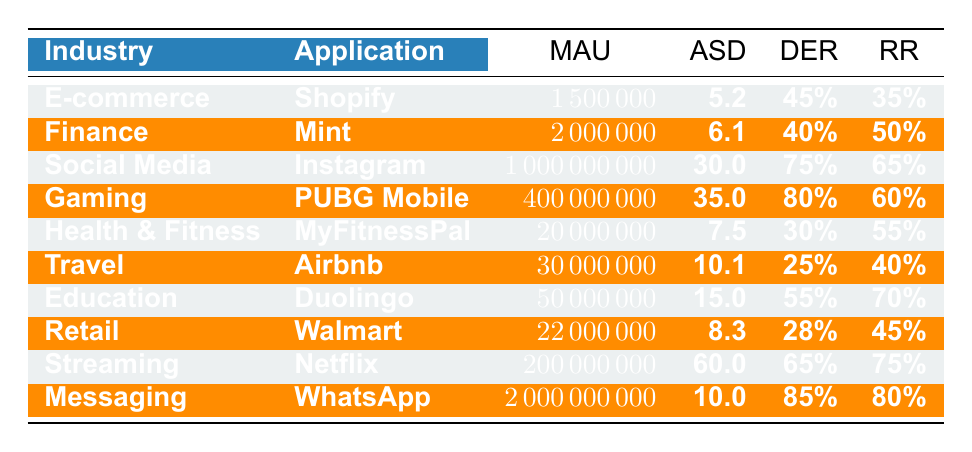What is the Monthly Active Users for WhatsApp? The table lists WhatsApp under the Messaging industry with a Monthly Active Users (MAU) count of 2,000,000,000.
Answer: 2,000,000,000 Which application has the longest Average Session Duration? From the table, PUBG Mobile has the highest Average Session Duration of 35.0 minutes among the listed applications.
Answer: PUBG Mobile What is the Daily Engagement Rate of Duolingo? The table indicates that Duolingo has a Daily Engagement Rate (DER) of 55%.
Answer: 55% Which industry has the highest Retention Rate and what is the value? By comparing the Retention Rates, Instagram has a Retention Rate of 65%, which is the highest in the table.
Answer: Social Media, 65% How do the Average Session Durations of health & fitness and travel apps compare? MyFitnessPal has an Average Session Duration of 7.5 minutes, while Airbnb has 10.1 minutes. Since 10.1 is greater than 7.5, Airbnb has a longer duration.
Answer: Airbnb has a longer duration If we average the Daily Engagement Rates of all industries, what is the result? The Daily Engagement Rates are: 45%, 40%, 75%, 80%, 30%, 25%, 55%, 28%, 65%, 85%. Adding these, we get 453% and dividing by 10 gives an average of 45.3%.
Answer: 45.3% Is the Retention Rate for Mint higher than that of Shopify? According to the table, Mint's Retention Rate is 50%, while Shopify's is 35%. Therefore, the statement is true that Mint's is higher.
Answer: Yes Which application has the lowest Daily Engagement Rate? The table shows that Airbnb has the lowest Daily Engagement Rate of 25%, which is lower than all other applications listed.
Answer: Airbnb, 25% What is the difference in Monthly Active Users between Instagram and Shopify? Instagram has 1,000,000,000 Monthly Active Users, while Shopify has 1,500,000. The difference is 1,000,000,000 - 1,500,000 = 998,500,000.
Answer: 998,500,000 Are there more Monthly Active Users in Gaming compared to Health & Fitness? PUBG Mobile in Gaming has 400,000,000 MAU, and MyFitnessPal in Health & Fitness has 20,000,000 MAU. Since 400,000,000 is greater than 20,000,000, the answer is yes.
Answer: Yes Calculate the sum of Monthly Active Users for the Social Media and Streaming industries. Instagram has 1,000,000,000 and Netflix has 200,000,000. Adding these gives us 1,200,000,000 for both industries combined.
Answer: 1,200,000,000 